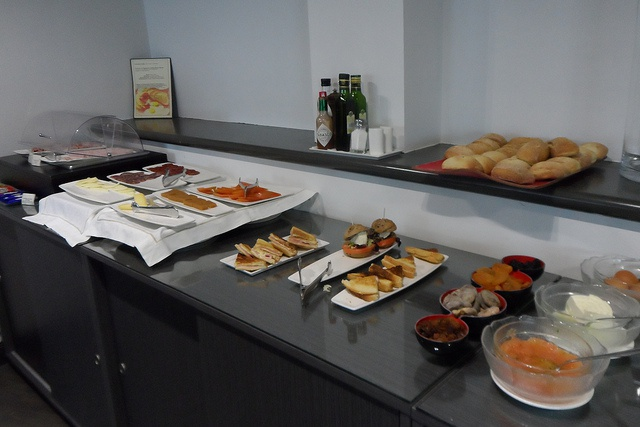Describe the objects in this image and their specific colors. I can see bowl in gray, brown, and darkgray tones, bowl in gray, darkgray, and tan tones, bowl in gray, black, and maroon tones, bowl in gray and brown tones, and bowl in gray, black, and maroon tones in this image. 